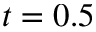Convert formula to latex. <formula><loc_0><loc_0><loc_500><loc_500>t = 0 . 5</formula> 